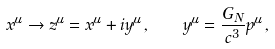Convert formula to latex. <formula><loc_0><loc_0><loc_500><loc_500>x ^ { \mu } \rightarrow z ^ { \mu } = x ^ { \mu } + i y ^ { \mu } \, , \quad y ^ { \mu } = \frac { G _ { N } } { c ^ { 3 } } p ^ { \mu } \, ,</formula> 